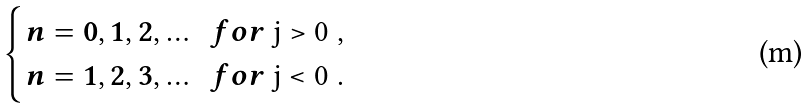<formula> <loc_0><loc_0><loc_500><loc_500>\begin{cases} n = 0 , 1 , 2 , \dots \ \ f o r $ j > 0 $ , \\ n = 1 , 2 , 3 , \dots \ \ f o r $ j < 0 $ . \end{cases}</formula> 